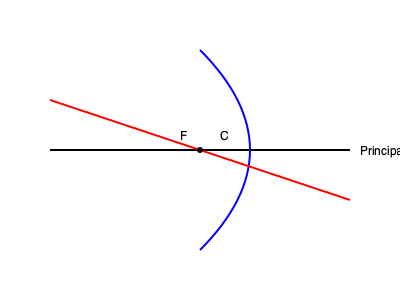In the ray diagram shown, a convex lens is represented by the blue curve. An incident ray (red) passes through the focal point F and emerges from the lens. How does the angle of refraction compare to the angle of incidence for this ray? Explain your reasoning using the principles of refraction and the properties of convex lenses. To understand this situation, let's break it down step-by-step:

1. Recall that a convex lens is thicker in the middle and thinner at the edges.

2. The focal point (F) is where parallel rays converge after passing through the lens.

3. In this diagram, the incident ray (the first part of the red line) is directed towards the focal point F.

4. When a ray passes through the focal point of a convex lens, it emerges parallel to the principal axis. This is a key property of convex lenses.

5. The angle of incidence ($\theta_i$) is the angle between the incident ray and the normal to the lens surface at the point of incidence.

6. The angle of refraction ($\theta_r$) is the angle between the refracted ray and the normal to the lens surface at the point of emergence.

7. In this case, because the emergent ray is parallel to the principal axis, the angle of refraction is effectively zero.

8. The angle of incidence, however, is clearly non-zero as the incident ray is not parallel to the principal axis.

9. Therefore, the angle of refraction must be smaller than the angle of incidence.

This behavior is consistent with Snell's law of refraction:

$$ n_1 \sin(\theta_1) = n_2 \sin(\theta_2) $$

Where $n_1$ and $n_2$ are the refractive indices of the two media, and $\theta_1$ and $\theta_2$ are the angles of incidence and refraction, respectively.
Answer: The angle of refraction is smaller than the angle of incidence. 